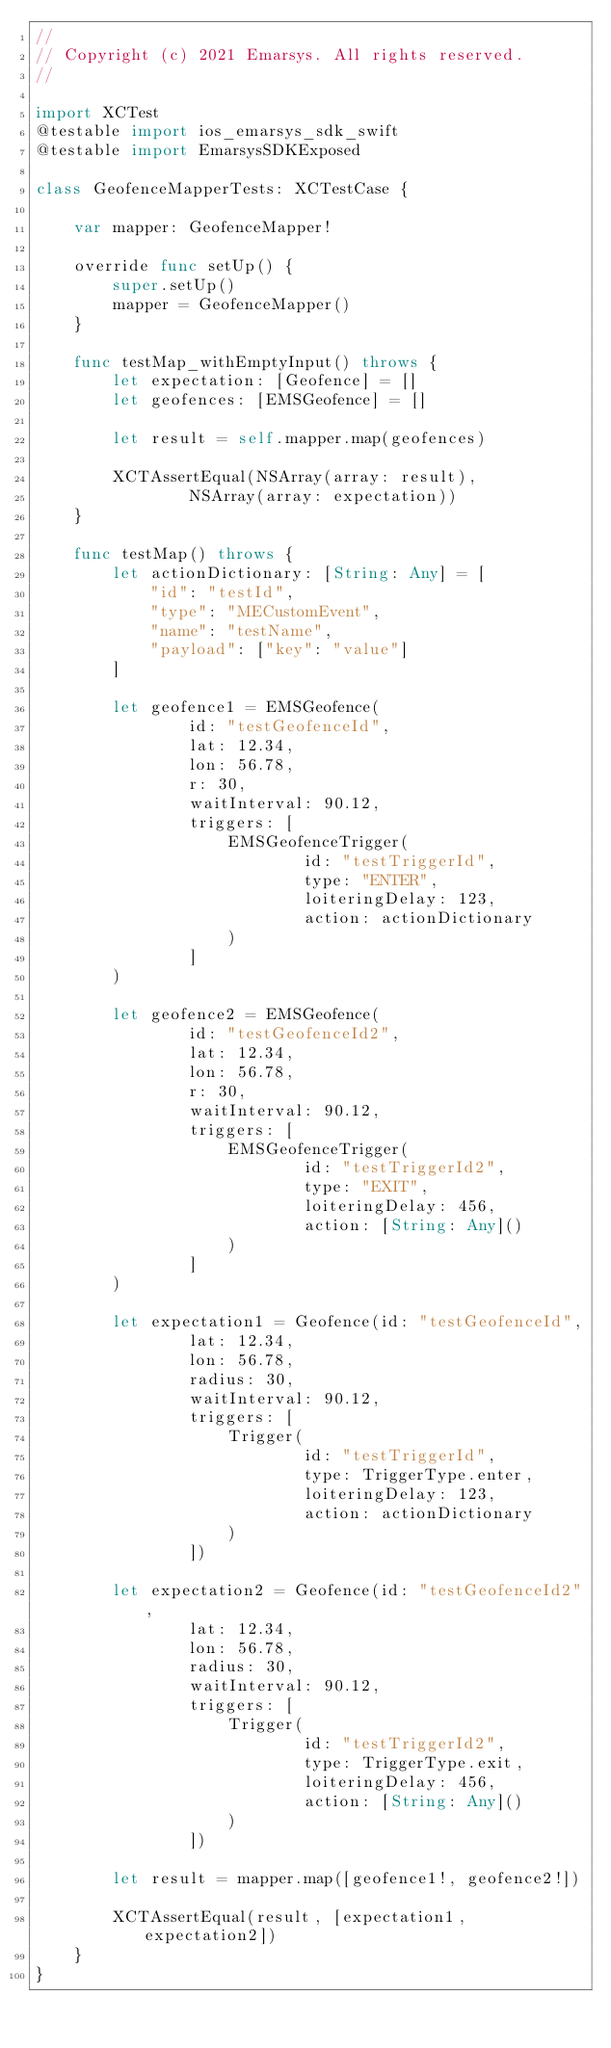Convert code to text. <code><loc_0><loc_0><loc_500><loc_500><_Swift_>//
// Copyright (c) 2021 Emarsys. All rights reserved.
//

import XCTest
@testable import ios_emarsys_sdk_swift
@testable import EmarsysSDKExposed

class GeofenceMapperTests: XCTestCase {

    var mapper: GeofenceMapper!

    override func setUp() {
        super.setUp()
        mapper = GeofenceMapper()
    }

    func testMap_withEmptyInput() throws {
        let expectation: [Geofence] = []
        let geofences: [EMSGeofence] = []

        let result = self.mapper.map(geofences)

        XCTAssertEqual(NSArray(array: result),
                NSArray(array: expectation))
    }

    func testMap() throws {
        let actionDictionary: [String: Any] = [
            "id": "testId",
            "type": "MECustomEvent",
            "name": "testName",
            "payload": ["key": "value"]
        ]

        let geofence1 = EMSGeofence(
                id: "testGeofenceId",
                lat: 12.34,
                lon: 56.78,
                r: 30,
                waitInterval: 90.12,
                triggers: [
                    EMSGeofenceTrigger(
                            id: "testTriggerId",
                            type: "ENTER",
                            loiteringDelay: 123,
                            action: actionDictionary
                    )
                ]
        )

        let geofence2 = EMSGeofence(
                id: "testGeofenceId2",
                lat: 12.34,
                lon: 56.78,
                r: 30,
                waitInterval: 90.12,
                triggers: [
                    EMSGeofenceTrigger(
                            id: "testTriggerId2",
                            type: "EXIT",
                            loiteringDelay: 456,
                            action: [String: Any]()
                    )
                ]
        )

        let expectation1 = Geofence(id: "testGeofenceId",
                lat: 12.34,
                lon: 56.78,
                radius: 30,
                waitInterval: 90.12,
                triggers: [
                    Trigger(
                            id: "testTriggerId",
                            type: TriggerType.enter,
                            loiteringDelay: 123,
                            action: actionDictionary
                    )
                ])

        let expectation2 = Geofence(id: "testGeofenceId2",
                lat: 12.34,
                lon: 56.78,
                radius: 30,
                waitInterval: 90.12,
                triggers: [
                    Trigger(
                            id: "testTriggerId2",
                            type: TriggerType.exit,
                            loiteringDelay: 456,
                            action: [String: Any]()
                    )
                ])

        let result = mapper.map([geofence1!, geofence2!])

        XCTAssertEqual(result, [expectation1, expectation2])
    }
}
</code> 